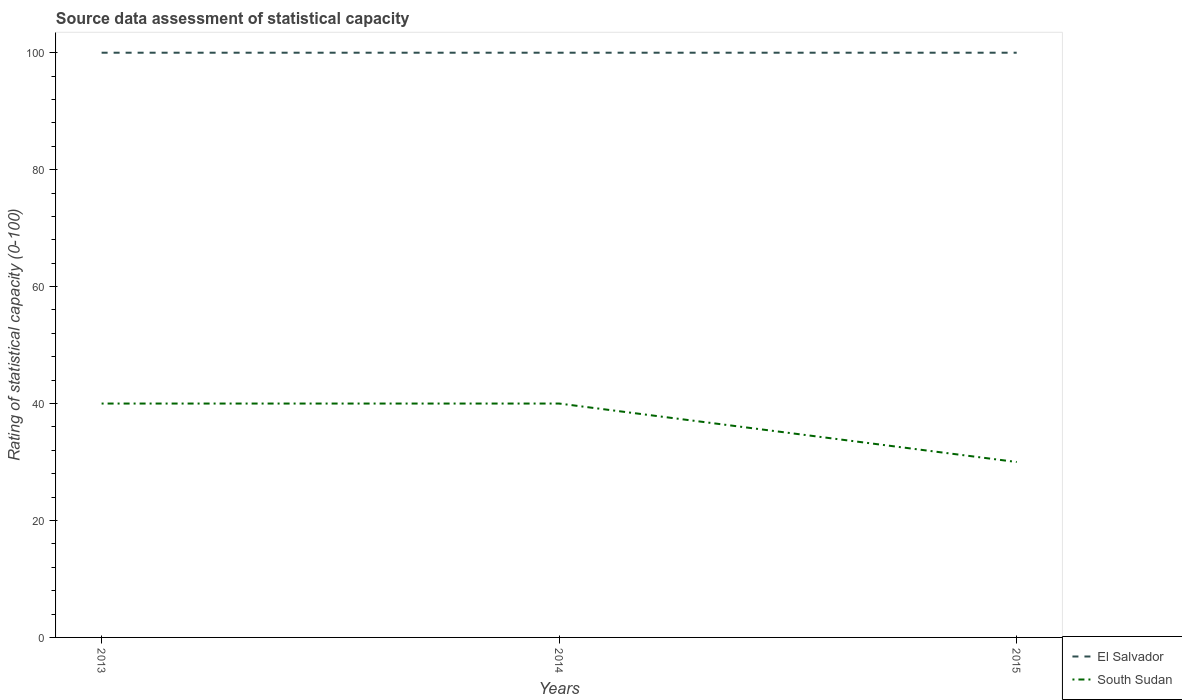Does the line corresponding to El Salvador intersect with the line corresponding to South Sudan?
Your answer should be compact. No. Is the number of lines equal to the number of legend labels?
Offer a terse response. Yes. In which year was the rating of statistical capacity in El Salvador maximum?
Your answer should be compact. 2013. What is the total rating of statistical capacity in South Sudan in the graph?
Make the answer very short. 0. What is the difference between the highest and the second highest rating of statistical capacity in El Salvador?
Your answer should be compact. 0. How many lines are there?
Offer a very short reply. 2. What is the difference between two consecutive major ticks on the Y-axis?
Ensure brevity in your answer.  20. Does the graph contain any zero values?
Your answer should be very brief. No. Does the graph contain grids?
Provide a succinct answer. No. How many legend labels are there?
Your answer should be very brief. 2. What is the title of the graph?
Provide a succinct answer. Source data assessment of statistical capacity. Does "Israel" appear as one of the legend labels in the graph?
Your answer should be compact. No. What is the label or title of the Y-axis?
Your answer should be compact. Rating of statistical capacity (0-100). What is the Rating of statistical capacity (0-100) in South Sudan in 2014?
Ensure brevity in your answer.  40. What is the Rating of statistical capacity (0-100) of South Sudan in 2015?
Make the answer very short. 30. Across all years, what is the minimum Rating of statistical capacity (0-100) in South Sudan?
Provide a short and direct response. 30. What is the total Rating of statistical capacity (0-100) in El Salvador in the graph?
Your answer should be compact. 300. What is the total Rating of statistical capacity (0-100) in South Sudan in the graph?
Keep it short and to the point. 110. What is the difference between the Rating of statistical capacity (0-100) in South Sudan in 2013 and that in 2014?
Give a very brief answer. 0. What is the difference between the Rating of statistical capacity (0-100) of South Sudan in 2013 and that in 2015?
Provide a succinct answer. 10. What is the difference between the Rating of statistical capacity (0-100) in El Salvador in 2014 and that in 2015?
Give a very brief answer. 0. What is the difference between the Rating of statistical capacity (0-100) in South Sudan in 2014 and that in 2015?
Provide a succinct answer. 10. What is the difference between the Rating of statistical capacity (0-100) in El Salvador in 2013 and the Rating of statistical capacity (0-100) in South Sudan in 2015?
Make the answer very short. 70. What is the average Rating of statistical capacity (0-100) in El Salvador per year?
Your response must be concise. 100. What is the average Rating of statistical capacity (0-100) in South Sudan per year?
Offer a very short reply. 36.67. In the year 2013, what is the difference between the Rating of statistical capacity (0-100) of El Salvador and Rating of statistical capacity (0-100) of South Sudan?
Your answer should be compact. 60. What is the ratio of the Rating of statistical capacity (0-100) of South Sudan in 2013 to that in 2014?
Offer a terse response. 1. What is the ratio of the Rating of statistical capacity (0-100) in South Sudan in 2014 to that in 2015?
Your answer should be very brief. 1.33. What is the difference between the highest and the second highest Rating of statistical capacity (0-100) in El Salvador?
Offer a terse response. 0. What is the difference between the highest and the second highest Rating of statistical capacity (0-100) of South Sudan?
Keep it short and to the point. 0. What is the difference between the highest and the lowest Rating of statistical capacity (0-100) in El Salvador?
Offer a terse response. 0. 